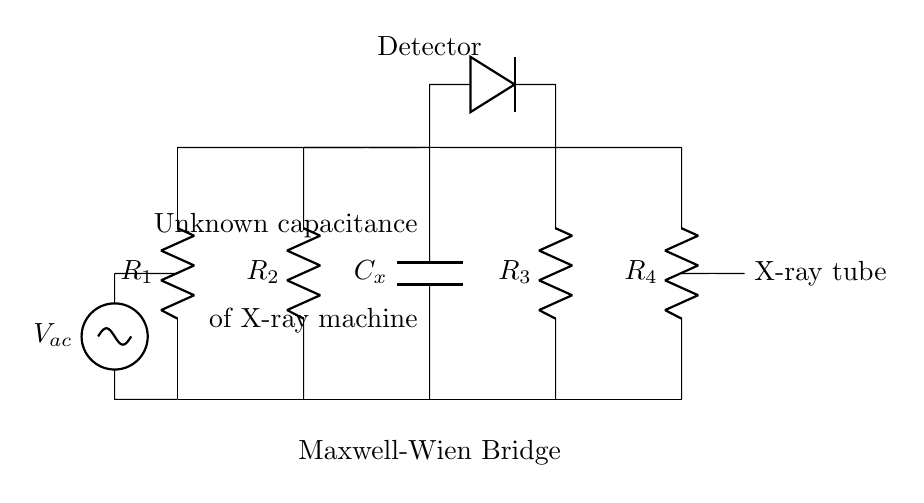What is the total number of resistors in the circuit? There are four resistors labeled R1, R2, R3, and R4, as seen in the diagram. Each resistor is represented along the vertical connections between the horizontal wires.
Answer: Four What component is represented by C_x? C_x is labeled as a capacitor in the circuit diagram, indicating that it is used for measuring unknown capacitance.
Answer: Capacitor What is the purpose of the detector in the circuit? The detector is placed at the output of the bridge, serving to measure the balance condition between the two sides of the bridge circuit, which indicates when the unknown capacitance matches the reference values.
Answer: Measure balance How many components are in series with R1? R1 is in series with one capacitor (C_x) and one other resistor (R2) above it, indicating that there are two components in series with R1 when considering the overall flow.
Answer: Two What type of bridge is represented in this circuit? The circuit represents a Maxwell-Wien Bridge, specifically designed for measuring capacitance, which is indicated in the labeling below the circuit.
Answer: Maxwell-Wien Bridge What is the supply voltage labeled in the diagram? The AC voltage source is labeled as V_ac, indicating it is the supply voltage for this circuit, positioned at the left side of the diagram.
Answer: V_ac Why is there an unknown capacitance in the circuit? The presence of the unknown capacitance (C_x) allows for the measurement of varying capacitance values, crucial for calibrating and testing in early X-ray machines, making it a key feature of this bridge design.
Answer: Calibration purpose 